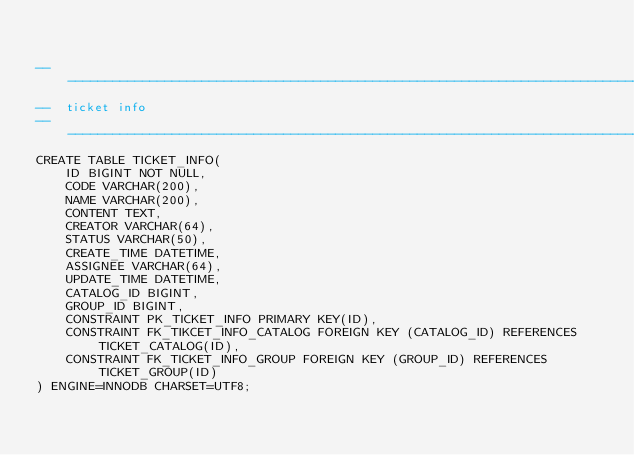Convert code to text. <code><loc_0><loc_0><loc_500><loc_500><_SQL_>

-------------------------------------------------------------------------------
--  ticket info
-------------------------------------------------------------------------------
CREATE TABLE TICKET_INFO(
    ID BIGINT NOT NULL,
    CODE VARCHAR(200),
    NAME VARCHAR(200),
    CONTENT TEXT,
    CREATOR VARCHAR(64),
    STATUS VARCHAR(50),
    CREATE_TIME DATETIME,
    ASSIGNEE VARCHAR(64),
    UPDATE_TIME DATETIME,
    CATALOG_ID BIGINT,
    GROUP_ID BIGINT,
    CONSTRAINT PK_TICKET_INFO PRIMARY KEY(ID),
    CONSTRAINT FK_TIKCET_INFO_CATALOG FOREIGN KEY (CATALOG_ID) REFERENCES TICKET_CATALOG(ID),
    CONSTRAINT FK_TICKET_INFO_GROUP FOREIGN KEY (GROUP_ID) REFERENCES TICKET_GROUP(ID)
) ENGINE=INNODB CHARSET=UTF8;














</code> 